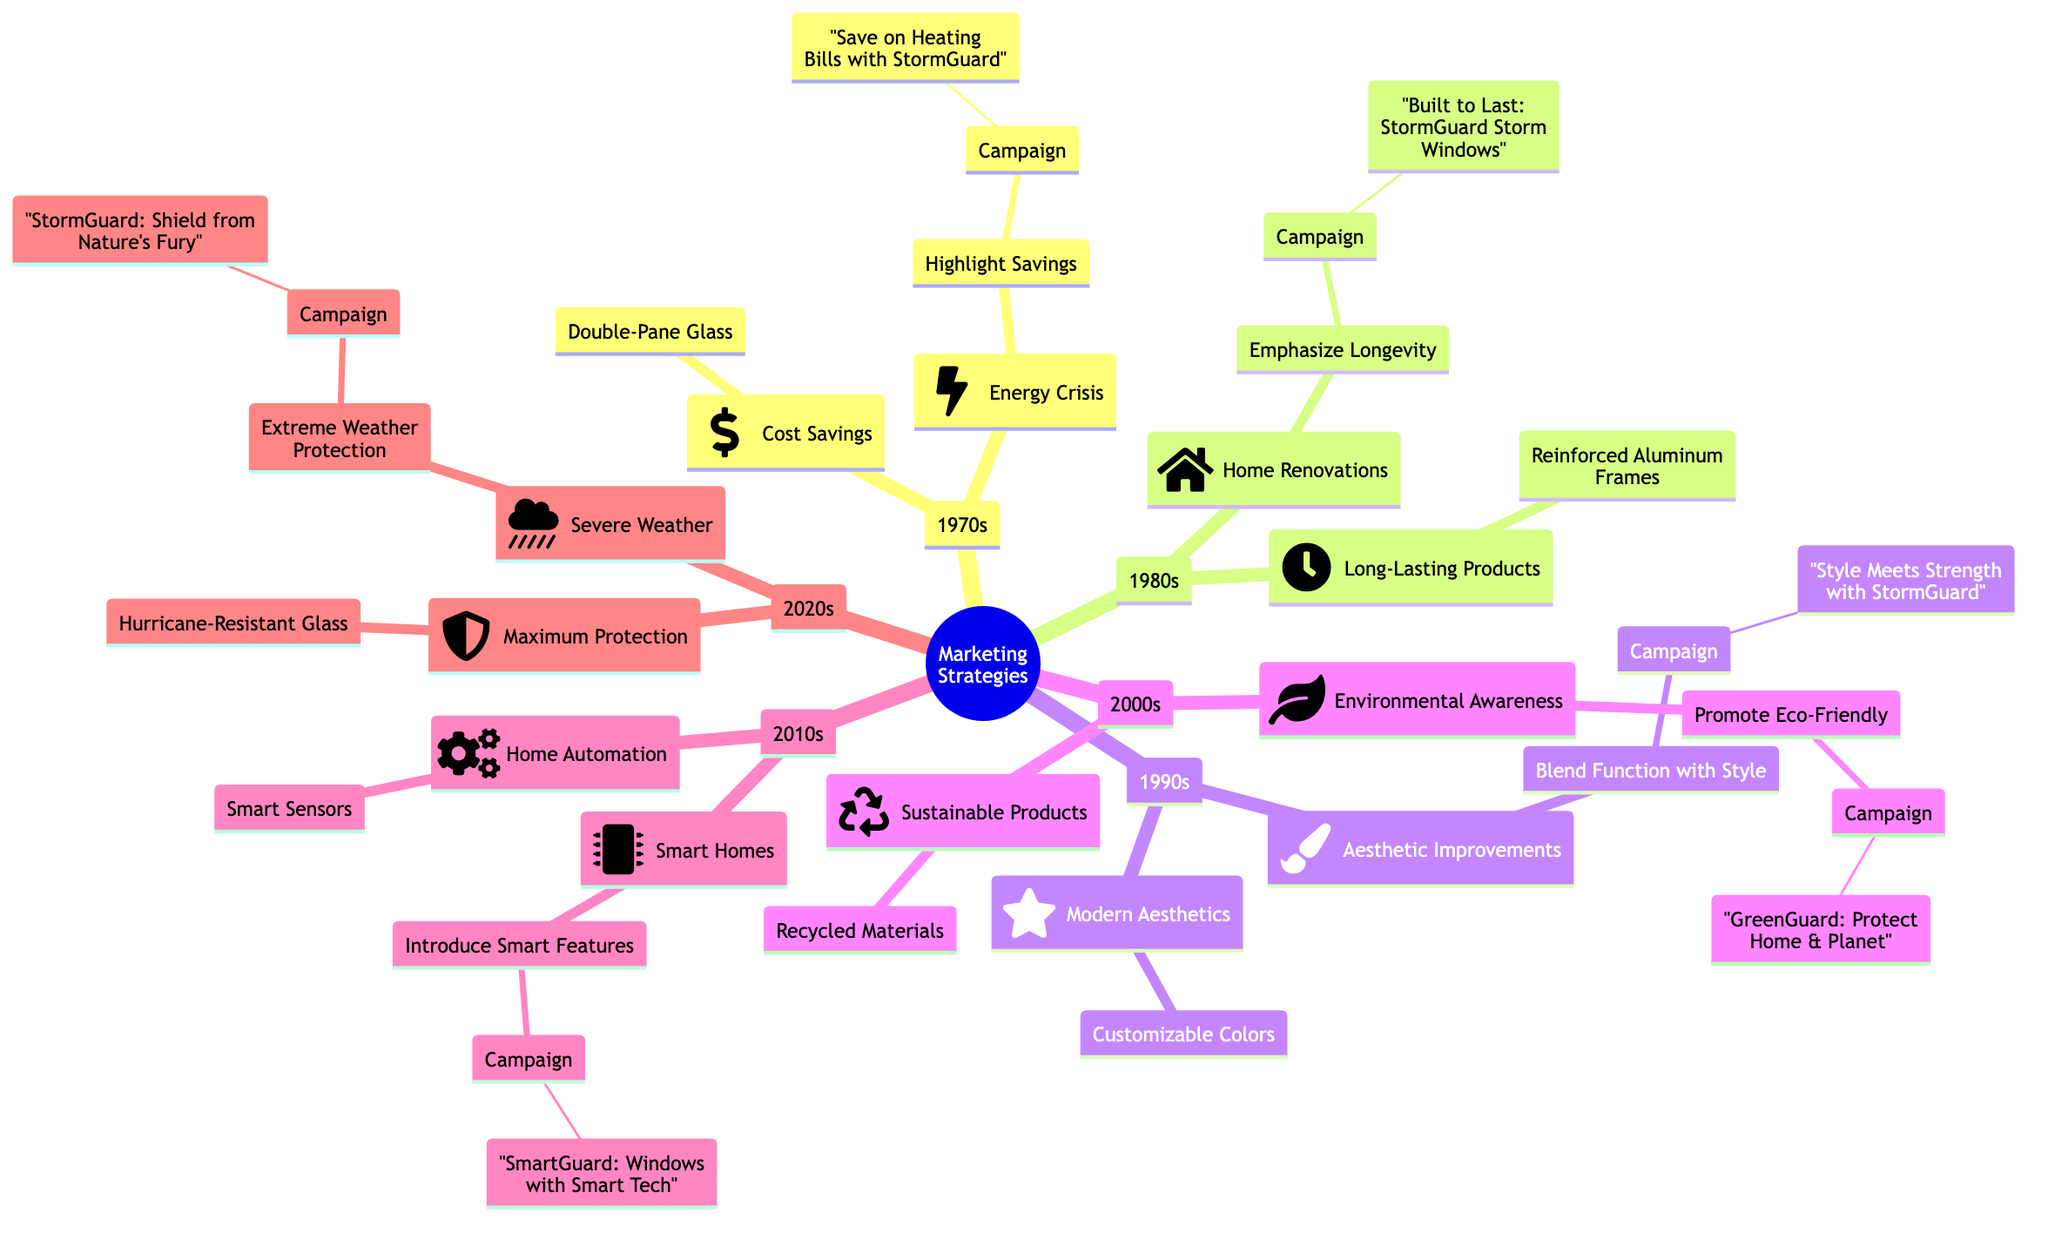What is the market trend in the 1990s? The 1990s has a market trend focused on aesthetic home improvements, as indicated in the diagram. This node is connected directly to its respective campaign and product feature, showing that consumer desires shifted towards design elements.
Answer: Aesthetic Improvements How many campaign nodes are there in total? To find the number of campaign nodes, count each "Campaign" entry listed under the various decades. There are six unique campaigns in the diagram, one for each marketing strategy segment.
Answer: 6 What consumer preference is highlighted in the 2000s? The consumer preference in the 2000s is for sustainable products, as specified below the market trend for growing environmental awareness. This reflects a shift in consumer values towards eco-friendly options.
Answer: Sustainable Products Which product feature is associated with the campaign "Built to Last: StormGuard Storm Windows"? This campaign, found in the 1980s segment, is connected with the product feature of reinforced aluminum frames. The relationship is explicitly defined in the tree structure, connecting durability to the marketing message.
Answer: Reinforced Aluminum Frames Which decade emphasizes smart home integration? The decade that emphasizes smart home integration is the 2010s. This time frame is explicitly stated with the corresponding market trend highlighting the rise of smart homes.
Answer: 2010s What strategy is used to promote eco-friendly benefits in the 2000s? The strategy to promote eco-friendly benefits in the 2000s is to promote eco-friendly benefits directly, which corresponds to the campaign associated with growing environmental awareness. This reflects a targeted approach in marketing.
Answer: Promote Eco-Friendly Benefits How is the theme of resilience addressed in the 2020s? In the 2020s, resilience is addressed through a focus on extreme weather protection, which aligns with the market trend of increased frequency of severe weather. This reflects a proactive approach to consumer concerns.
Answer: Extreme Weather Protection Which campaign is associated with the market trend of energy crisis? The campaign associated with the market trend of the energy crisis is "Save on Heating Bills with StormGuard." This is part of the first strategic response under the 1970s section focused on energy efficiency.
Answer: Save on Heating Bills with StormGuard What product feature reflects consumer preference for the 1990s? The product feature reflecting consumer preference in the 1990s is customizable color options. This indicates a trend toward providing consumers with design choices that fit modern aesthetics.
Answer: Customizable Color Options 